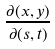Convert formula to latex. <formula><loc_0><loc_0><loc_500><loc_500>\frac { \partial ( x , y ) } { \partial ( s , t ) }</formula> 